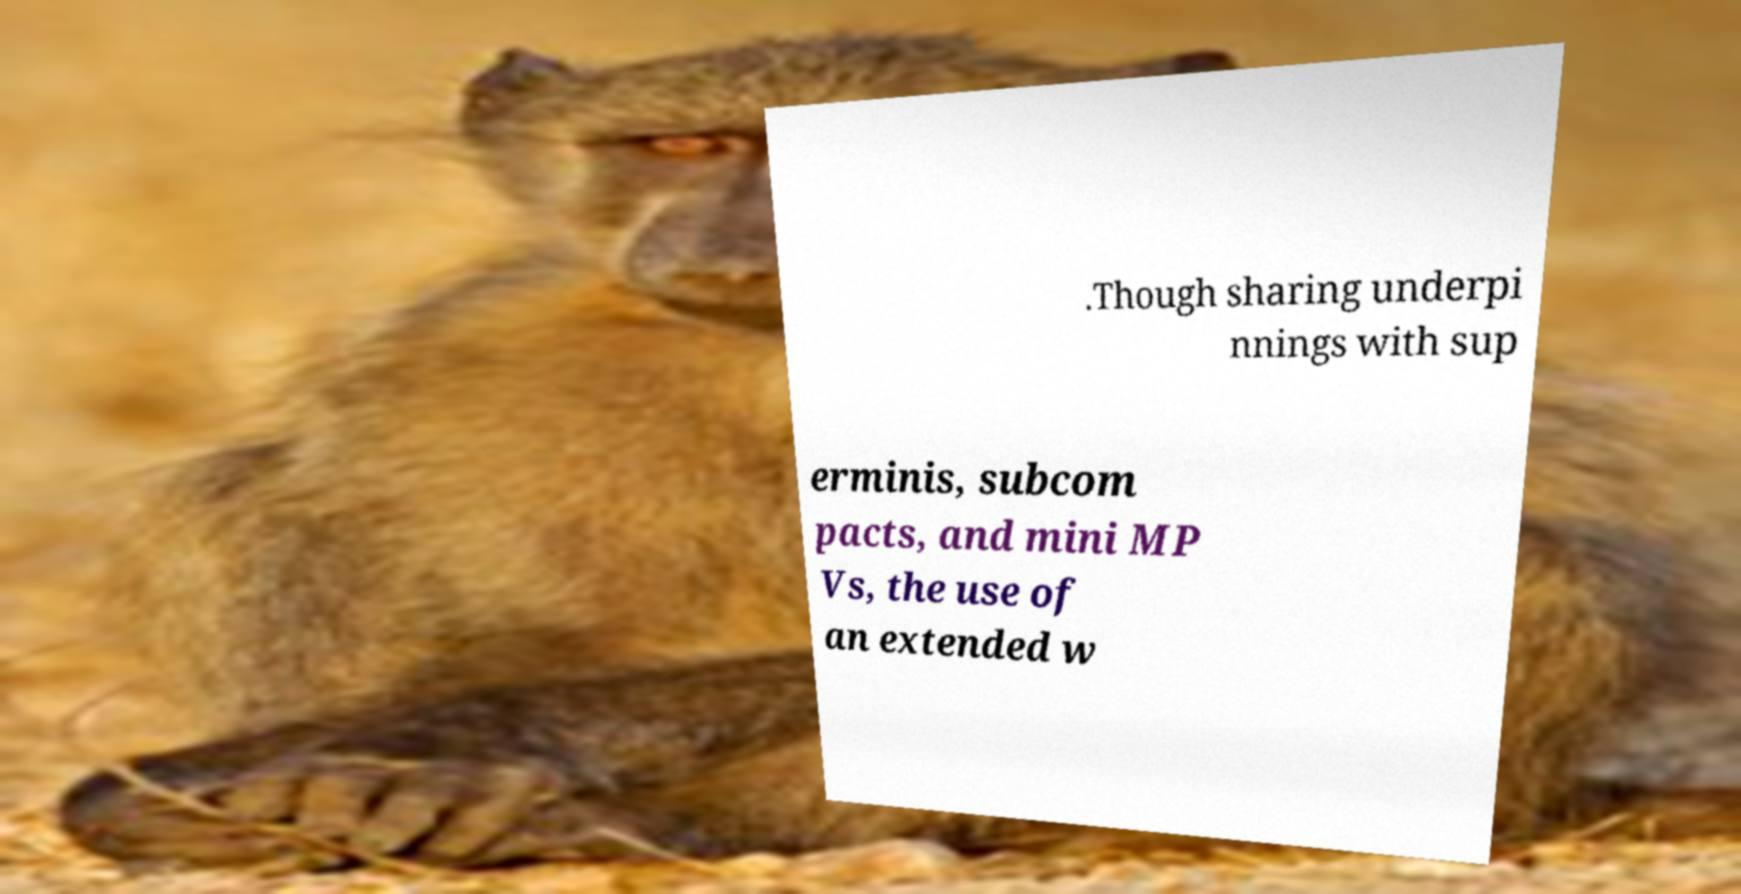There's text embedded in this image that I need extracted. Can you transcribe it verbatim? .Though sharing underpi nnings with sup erminis, subcom pacts, and mini MP Vs, the use of an extended w 